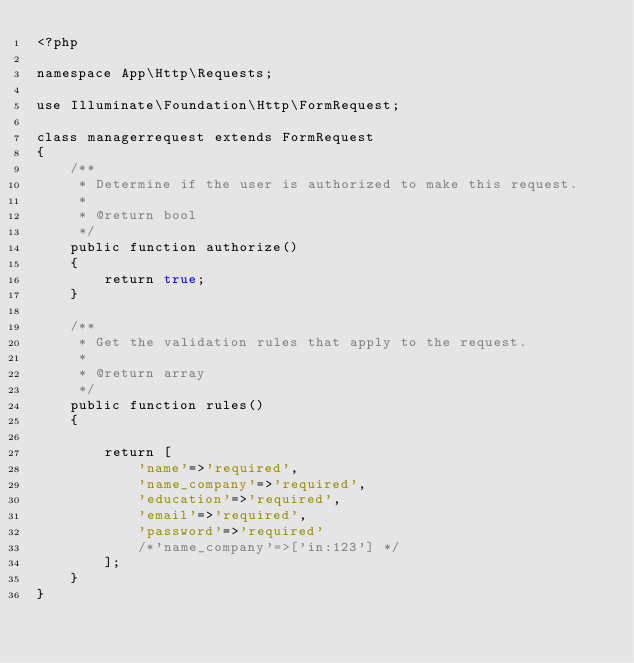Convert code to text. <code><loc_0><loc_0><loc_500><loc_500><_PHP_><?php

namespace App\Http\Requests;

use Illuminate\Foundation\Http\FormRequest;

class managerrequest extends FormRequest
{
    /**
     * Determine if the user is authorized to make this request.
     *
     * @return bool
     */
    public function authorize()
    {
        return true;
    }

    /**
     * Get the validation rules that apply to the request.
     *
     * @return array
     */
    public function rules()
    {
       
        return [
            'name'=>'required',
            'name_company'=>'required',
            'education'=>'required',
            'email'=>'required',
            'password'=>'required'
            /*'name_company'=>['in:123'] */
        ];
    }
}
</code> 